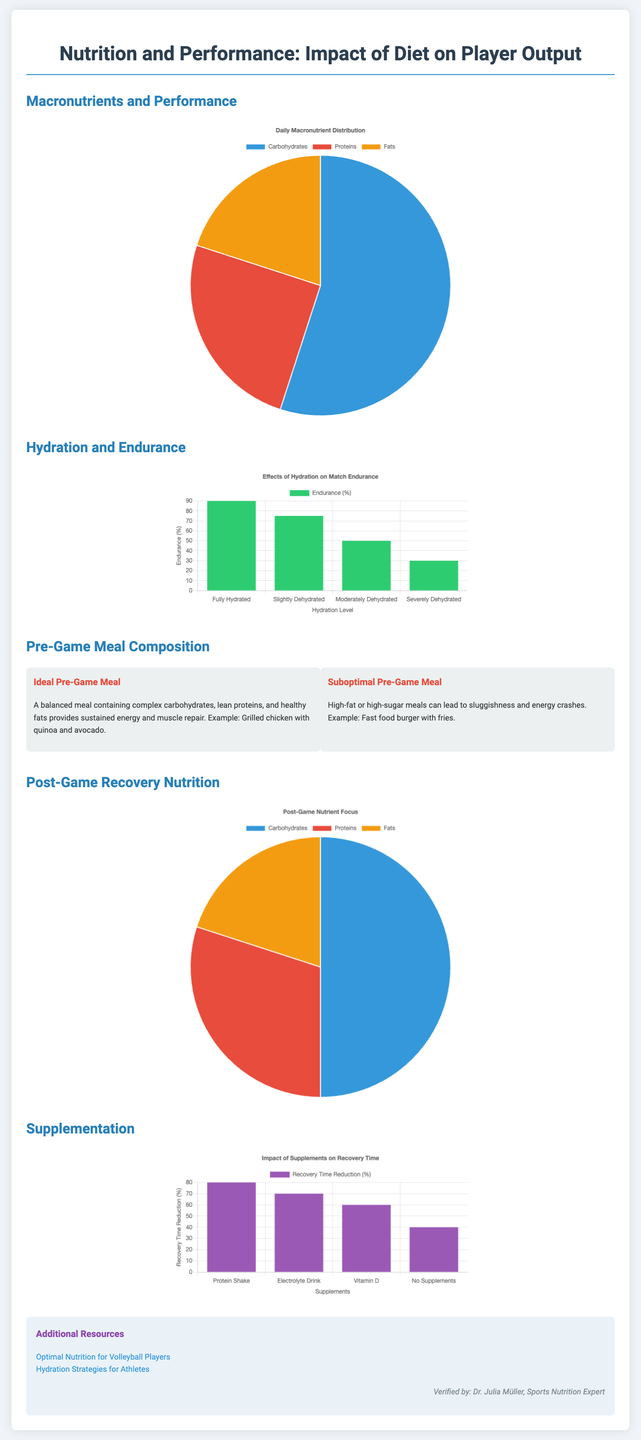What percentage of carbohydrates is recommended in daily macronutrient distribution? The pie chart for daily macronutrient distribution shows that carbohydrates make up 55% of the diet.
Answer: 55% What is the endurance percentage for slightly dehydrated athletes? The bar chart shows that slightly dehydrated athletes have an endurance percentage of 75%.
Answer: 75% What is included in an ideal pre-game meal? The ideal pre-game meal is described as a balanced meal containing complex carbohydrates, lean proteins, and healthy fats.
Answer: Balanced meal What percentage of post-game nutrition should focus on carbohydrates? The pie chart for post-game nutrient focus indicates that carbohydrates should comprise 50% of post-game nutrition.
Answer: 50% Which supplement shows the highest recovery time reduction? The bar chart on supplementation shows that protein shakes have the highest recovery time reduction percentage at 80%.
Answer: Protein Shake What is the hydration level percentage for fully hydrated athletes? The hydration bar chart indicates that fully hydrated athletes have an endurance level of 90%.
Answer: 90% What color represents proteins in the macronutrient chart? The macronutrient chart uses red to represent proteins.
Answer: Red What is a suboptimal pre-game meal example provided in the infographic? The infographic mentions fast food burger with fries as an example of a suboptimal pre-game meal.
Answer: Fast food burger with fries How does hydration level affect match endurance? The bar chart shows a direct correlation, with endurance decreasing as hydration level decreases.
Answer: Direct correlation 